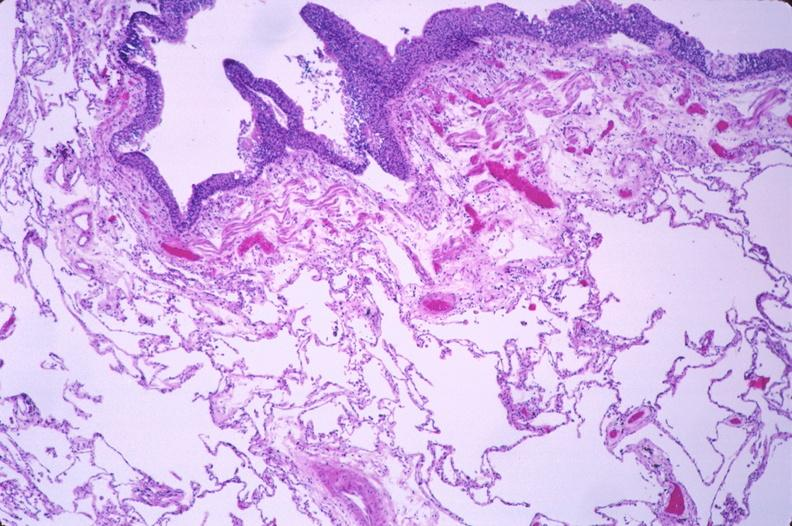s respiratory present?
Answer the question using a single word or phrase. Yes 